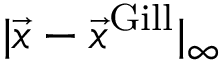<formula> <loc_0><loc_0><loc_500><loc_500>| \vec { x } - \vec { x } ^ { G i l l } | _ { \infty }</formula> 